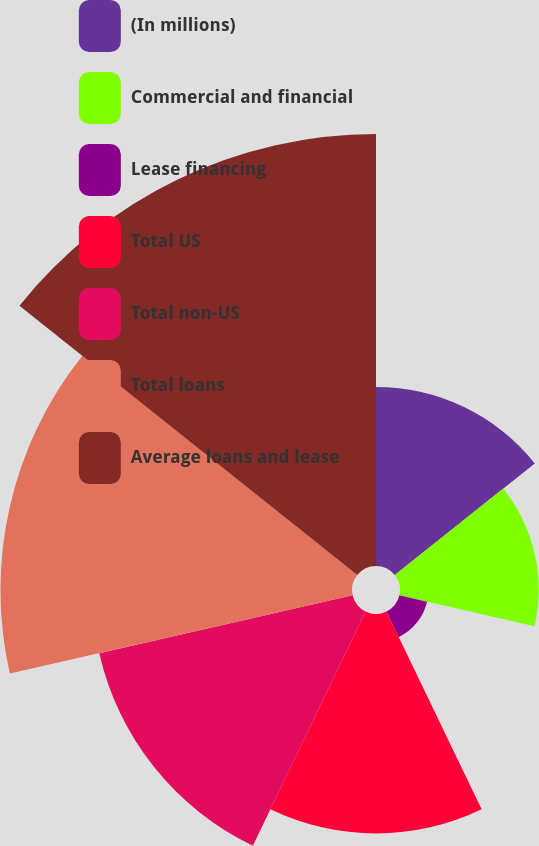Convert chart to OTSL. <chart><loc_0><loc_0><loc_500><loc_500><pie_chart><fcel>(In millions)<fcel>Commercial and financial<fcel>Lease financing<fcel>Total US<fcel>Total non-US<fcel>Total loans<fcel>Average loans and lease<nl><fcel>11.13%<fcel>8.62%<fcel>1.76%<fcel>13.64%<fcel>16.15%<fcel>21.85%<fcel>26.85%<nl></chart> 